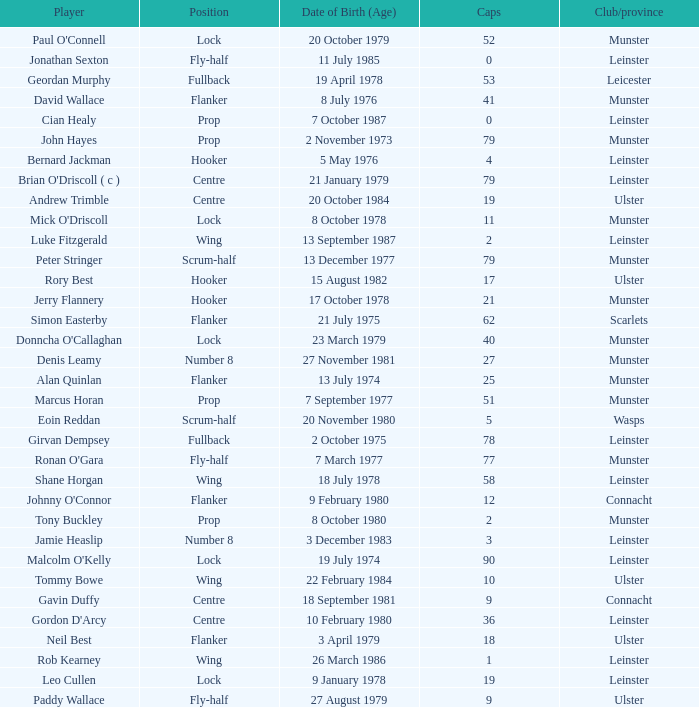What is the total of Caps when player born 13 December 1977? 79.0. 